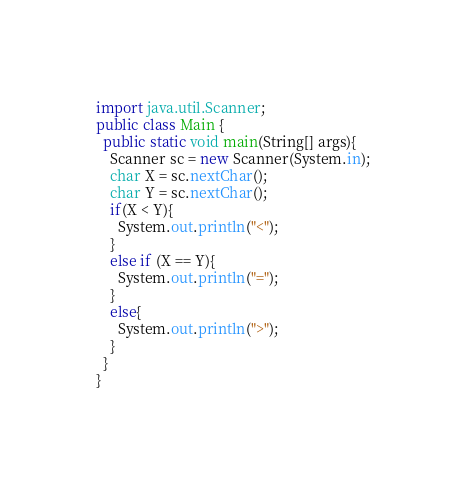<code> <loc_0><loc_0><loc_500><loc_500><_Java_>import java.util.Scanner;
public class Main {
  public static void main(String[] args){
    Scanner sc = new Scanner(System.in);
    char X = sc.nextChar();
    char Y = sc.nextChar();
    if(X < Y){
      System.out.println("<");
    }
    else if (X == Y){
      System.out.println("=");
    }
    else{
      System.out.println(">");
    }
  }
}
</code> 